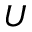<formula> <loc_0><loc_0><loc_500><loc_500>U</formula> 